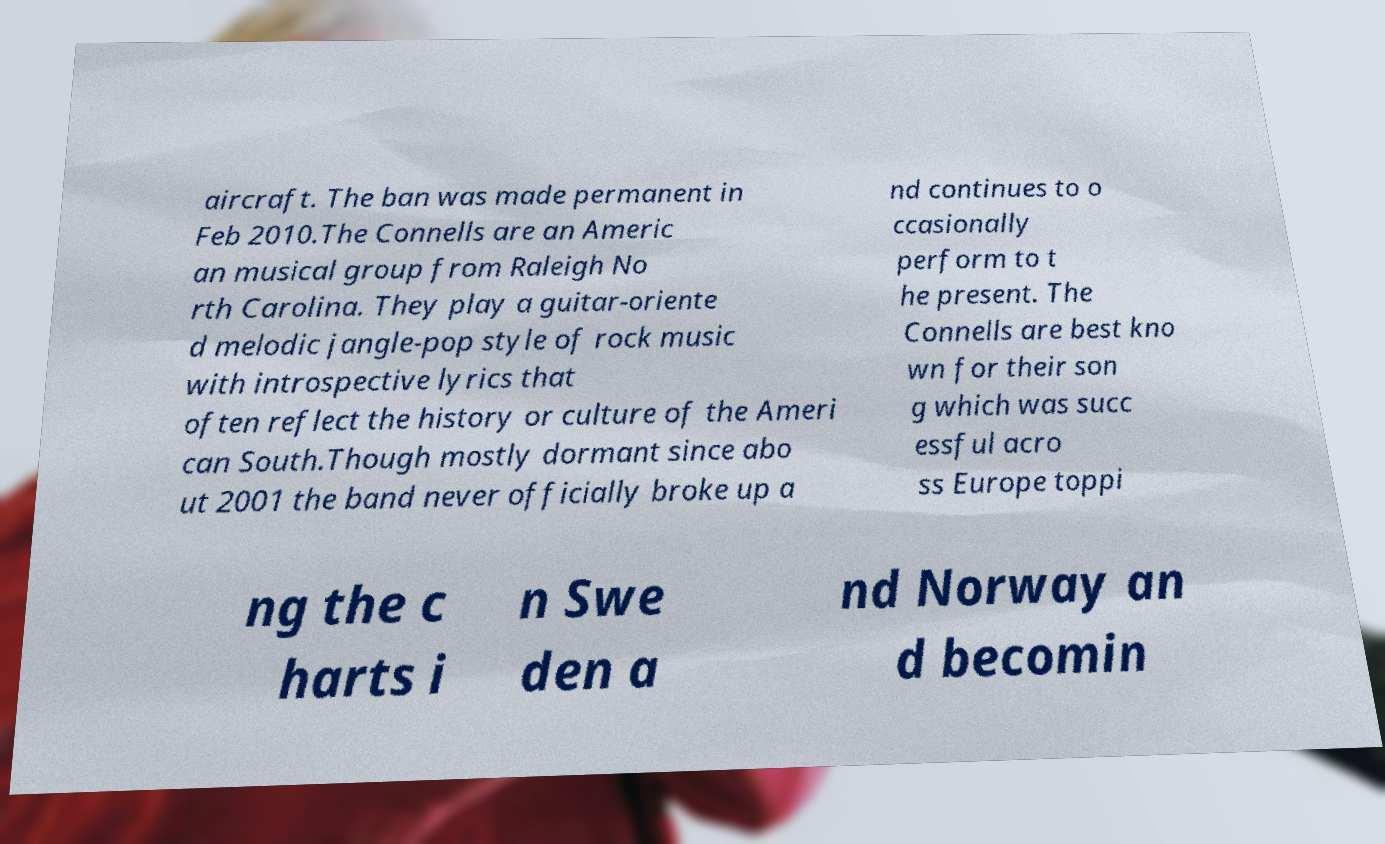Could you assist in decoding the text presented in this image and type it out clearly? aircraft. The ban was made permanent in Feb 2010.The Connells are an Americ an musical group from Raleigh No rth Carolina. They play a guitar-oriente d melodic jangle-pop style of rock music with introspective lyrics that often reflect the history or culture of the Ameri can South.Though mostly dormant since abo ut 2001 the band never officially broke up a nd continues to o ccasionally perform to t he present. The Connells are best kno wn for their son g which was succ essful acro ss Europe toppi ng the c harts i n Swe den a nd Norway an d becomin 